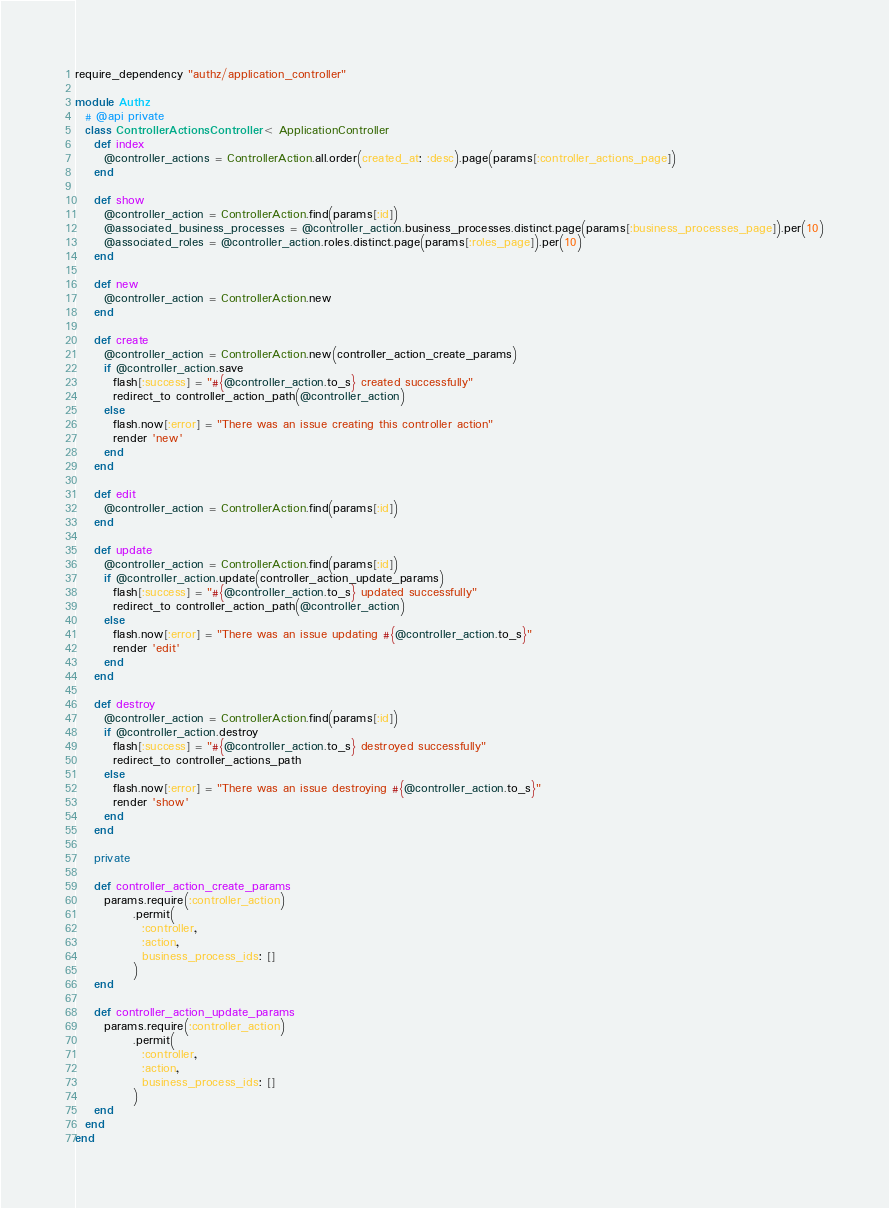<code> <loc_0><loc_0><loc_500><loc_500><_Ruby_>require_dependency "authz/application_controller"

module Authz
  # @api private
  class ControllerActionsController < ApplicationController
    def index
      @controller_actions = ControllerAction.all.order(created_at: :desc).page(params[:controller_actions_page])
    end

    def show
      @controller_action = ControllerAction.find(params[:id])
      @associated_business_processes = @controller_action.business_processes.distinct.page(params[:business_processes_page]).per(10)
      @associated_roles = @controller_action.roles.distinct.page(params[:roles_page]).per(10)
    end

    def new
      @controller_action = ControllerAction.new
    end

    def create
      @controller_action = ControllerAction.new(controller_action_create_params)
      if @controller_action.save
        flash[:success] = "#{@controller_action.to_s} created successfully"
        redirect_to controller_action_path(@controller_action)
      else
        flash.now[:error] = "There was an issue creating this controller action"
        render 'new'
      end
    end

    def edit
      @controller_action = ControllerAction.find(params[:id])
    end

    def update
      @controller_action = ControllerAction.find(params[:id])
      if @controller_action.update(controller_action_update_params)
        flash[:success] = "#{@controller_action.to_s} updated successfully"
        redirect_to controller_action_path(@controller_action)
      else
        flash.now[:error] = "There was an issue updating #{@controller_action.to_s}"
        render 'edit'
      end
    end

    def destroy
      @controller_action = ControllerAction.find(params[:id])
      if @controller_action.destroy
        flash[:success] = "#{@controller_action.to_s} destroyed successfully"
        redirect_to controller_actions_path
      else
        flash.now[:error] = "There was an issue destroying #{@controller_action.to_s}"
        render 'show'
      end
    end

    private

    def controller_action_create_params
      params.require(:controller_action)
            .permit(
              :controller,
              :action,
              business_process_ids: []
            )
    end

    def controller_action_update_params
      params.require(:controller_action)
            .permit(
              :controller,
              :action,
              business_process_ids: []
            )
    end
  end
end
</code> 